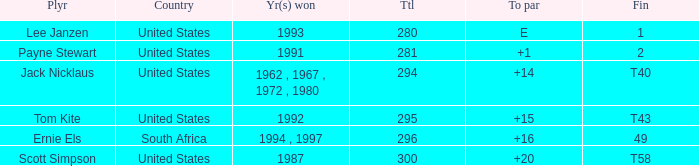What is the Total of the Player with a Finish of 1? 1.0. 